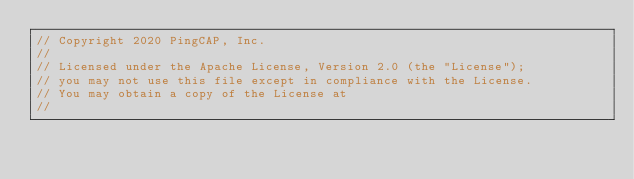<code> <loc_0><loc_0><loc_500><loc_500><_Go_>// Copyright 2020 PingCAP, Inc.
//
// Licensed under the Apache License, Version 2.0 (the "License");
// you may not use this file except in compliance with the License.
// You may obtain a copy of the License at
//</code> 